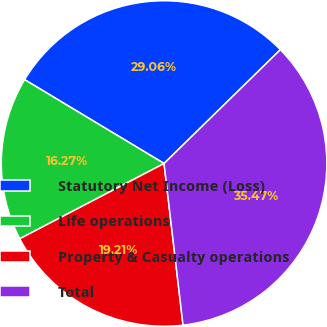Convert chart to OTSL. <chart><loc_0><loc_0><loc_500><loc_500><pie_chart><fcel>Statutory Net Income (Loss)<fcel>Life operations<fcel>Property & Casualty operations<fcel>Total<nl><fcel>29.06%<fcel>16.27%<fcel>19.21%<fcel>35.47%<nl></chart> 